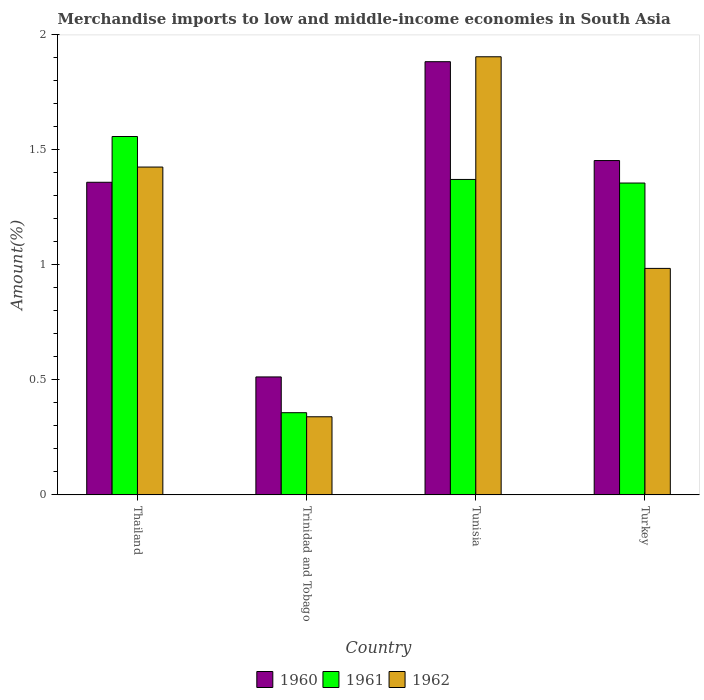How many groups of bars are there?
Your answer should be very brief. 4. Are the number of bars per tick equal to the number of legend labels?
Your answer should be very brief. Yes. How many bars are there on the 4th tick from the left?
Offer a terse response. 3. What is the label of the 1st group of bars from the left?
Your answer should be very brief. Thailand. In how many cases, is the number of bars for a given country not equal to the number of legend labels?
Keep it short and to the point. 0. What is the percentage of amount earned from merchandise imports in 1960 in Tunisia?
Offer a terse response. 1.88. Across all countries, what is the maximum percentage of amount earned from merchandise imports in 1961?
Your response must be concise. 1.56. Across all countries, what is the minimum percentage of amount earned from merchandise imports in 1960?
Provide a succinct answer. 0.51. In which country was the percentage of amount earned from merchandise imports in 1961 maximum?
Offer a terse response. Thailand. In which country was the percentage of amount earned from merchandise imports in 1960 minimum?
Offer a terse response. Trinidad and Tobago. What is the total percentage of amount earned from merchandise imports in 1961 in the graph?
Your answer should be compact. 4.64. What is the difference between the percentage of amount earned from merchandise imports in 1961 in Trinidad and Tobago and that in Tunisia?
Your answer should be very brief. -1.01. What is the difference between the percentage of amount earned from merchandise imports in 1961 in Turkey and the percentage of amount earned from merchandise imports in 1962 in Thailand?
Keep it short and to the point. -0.07. What is the average percentage of amount earned from merchandise imports in 1960 per country?
Make the answer very short. 1.3. What is the difference between the percentage of amount earned from merchandise imports of/in 1960 and percentage of amount earned from merchandise imports of/in 1961 in Tunisia?
Your response must be concise. 0.51. What is the ratio of the percentage of amount earned from merchandise imports in 1960 in Tunisia to that in Turkey?
Offer a very short reply. 1.3. Is the difference between the percentage of amount earned from merchandise imports in 1960 in Thailand and Turkey greater than the difference between the percentage of amount earned from merchandise imports in 1961 in Thailand and Turkey?
Provide a succinct answer. No. What is the difference between the highest and the second highest percentage of amount earned from merchandise imports in 1961?
Your answer should be very brief. 0.2. What is the difference between the highest and the lowest percentage of amount earned from merchandise imports in 1962?
Your answer should be very brief. 1.57. Is it the case that in every country, the sum of the percentage of amount earned from merchandise imports in 1961 and percentage of amount earned from merchandise imports in 1960 is greater than the percentage of amount earned from merchandise imports in 1962?
Provide a short and direct response. Yes. How many bars are there?
Provide a short and direct response. 12. Are all the bars in the graph horizontal?
Make the answer very short. No. How many countries are there in the graph?
Give a very brief answer. 4. Does the graph contain any zero values?
Your response must be concise. No. Does the graph contain grids?
Offer a terse response. No. What is the title of the graph?
Your answer should be compact. Merchandise imports to low and middle-income economies in South Asia. What is the label or title of the Y-axis?
Give a very brief answer. Amount(%). What is the Amount(%) of 1960 in Thailand?
Provide a succinct answer. 1.36. What is the Amount(%) in 1961 in Thailand?
Your answer should be compact. 1.56. What is the Amount(%) in 1962 in Thailand?
Your answer should be compact. 1.43. What is the Amount(%) of 1960 in Trinidad and Tobago?
Keep it short and to the point. 0.51. What is the Amount(%) of 1961 in Trinidad and Tobago?
Offer a very short reply. 0.36. What is the Amount(%) in 1962 in Trinidad and Tobago?
Offer a very short reply. 0.34. What is the Amount(%) in 1960 in Tunisia?
Your answer should be compact. 1.88. What is the Amount(%) in 1961 in Tunisia?
Offer a terse response. 1.37. What is the Amount(%) of 1962 in Tunisia?
Ensure brevity in your answer.  1.91. What is the Amount(%) in 1960 in Turkey?
Your answer should be compact. 1.45. What is the Amount(%) in 1961 in Turkey?
Give a very brief answer. 1.36. What is the Amount(%) in 1962 in Turkey?
Your answer should be compact. 0.98. Across all countries, what is the maximum Amount(%) of 1960?
Provide a short and direct response. 1.88. Across all countries, what is the maximum Amount(%) in 1961?
Provide a short and direct response. 1.56. Across all countries, what is the maximum Amount(%) of 1962?
Make the answer very short. 1.91. Across all countries, what is the minimum Amount(%) in 1960?
Make the answer very short. 0.51. Across all countries, what is the minimum Amount(%) of 1961?
Keep it short and to the point. 0.36. Across all countries, what is the minimum Amount(%) of 1962?
Keep it short and to the point. 0.34. What is the total Amount(%) of 1960 in the graph?
Provide a short and direct response. 5.21. What is the total Amount(%) of 1961 in the graph?
Offer a terse response. 4.64. What is the total Amount(%) in 1962 in the graph?
Provide a short and direct response. 4.66. What is the difference between the Amount(%) in 1960 in Thailand and that in Trinidad and Tobago?
Ensure brevity in your answer.  0.85. What is the difference between the Amount(%) of 1961 in Thailand and that in Trinidad and Tobago?
Make the answer very short. 1.2. What is the difference between the Amount(%) in 1962 in Thailand and that in Trinidad and Tobago?
Provide a short and direct response. 1.09. What is the difference between the Amount(%) in 1960 in Thailand and that in Tunisia?
Provide a short and direct response. -0.52. What is the difference between the Amount(%) of 1961 in Thailand and that in Tunisia?
Ensure brevity in your answer.  0.19. What is the difference between the Amount(%) in 1962 in Thailand and that in Tunisia?
Provide a short and direct response. -0.48. What is the difference between the Amount(%) of 1960 in Thailand and that in Turkey?
Your response must be concise. -0.09. What is the difference between the Amount(%) of 1961 in Thailand and that in Turkey?
Your answer should be very brief. 0.2. What is the difference between the Amount(%) of 1962 in Thailand and that in Turkey?
Ensure brevity in your answer.  0.44. What is the difference between the Amount(%) of 1960 in Trinidad and Tobago and that in Tunisia?
Provide a short and direct response. -1.37. What is the difference between the Amount(%) of 1961 in Trinidad and Tobago and that in Tunisia?
Ensure brevity in your answer.  -1.01. What is the difference between the Amount(%) in 1962 in Trinidad and Tobago and that in Tunisia?
Offer a terse response. -1.57. What is the difference between the Amount(%) in 1960 in Trinidad and Tobago and that in Turkey?
Ensure brevity in your answer.  -0.94. What is the difference between the Amount(%) in 1961 in Trinidad and Tobago and that in Turkey?
Your answer should be very brief. -1. What is the difference between the Amount(%) in 1962 in Trinidad and Tobago and that in Turkey?
Offer a terse response. -0.65. What is the difference between the Amount(%) of 1960 in Tunisia and that in Turkey?
Offer a very short reply. 0.43. What is the difference between the Amount(%) in 1961 in Tunisia and that in Turkey?
Offer a very short reply. 0.02. What is the difference between the Amount(%) in 1962 in Tunisia and that in Turkey?
Offer a very short reply. 0.92. What is the difference between the Amount(%) in 1960 in Thailand and the Amount(%) in 1962 in Trinidad and Tobago?
Your answer should be very brief. 1.02. What is the difference between the Amount(%) in 1961 in Thailand and the Amount(%) in 1962 in Trinidad and Tobago?
Your response must be concise. 1.22. What is the difference between the Amount(%) of 1960 in Thailand and the Amount(%) of 1961 in Tunisia?
Make the answer very short. -0.01. What is the difference between the Amount(%) in 1960 in Thailand and the Amount(%) in 1962 in Tunisia?
Ensure brevity in your answer.  -0.55. What is the difference between the Amount(%) of 1961 in Thailand and the Amount(%) of 1962 in Tunisia?
Give a very brief answer. -0.35. What is the difference between the Amount(%) of 1960 in Thailand and the Amount(%) of 1961 in Turkey?
Provide a succinct answer. 0. What is the difference between the Amount(%) in 1960 in Thailand and the Amount(%) in 1962 in Turkey?
Provide a succinct answer. 0.37. What is the difference between the Amount(%) of 1961 in Thailand and the Amount(%) of 1962 in Turkey?
Offer a very short reply. 0.57. What is the difference between the Amount(%) of 1960 in Trinidad and Tobago and the Amount(%) of 1961 in Tunisia?
Offer a very short reply. -0.86. What is the difference between the Amount(%) in 1960 in Trinidad and Tobago and the Amount(%) in 1962 in Tunisia?
Provide a short and direct response. -1.39. What is the difference between the Amount(%) of 1961 in Trinidad and Tobago and the Amount(%) of 1962 in Tunisia?
Keep it short and to the point. -1.55. What is the difference between the Amount(%) of 1960 in Trinidad and Tobago and the Amount(%) of 1961 in Turkey?
Provide a succinct answer. -0.84. What is the difference between the Amount(%) of 1960 in Trinidad and Tobago and the Amount(%) of 1962 in Turkey?
Make the answer very short. -0.47. What is the difference between the Amount(%) in 1961 in Trinidad and Tobago and the Amount(%) in 1962 in Turkey?
Provide a succinct answer. -0.63. What is the difference between the Amount(%) in 1960 in Tunisia and the Amount(%) in 1961 in Turkey?
Provide a succinct answer. 0.53. What is the difference between the Amount(%) of 1960 in Tunisia and the Amount(%) of 1962 in Turkey?
Provide a succinct answer. 0.9. What is the difference between the Amount(%) in 1961 in Tunisia and the Amount(%) in 1962 in Turkey?
Ensure brevity in your answer.  0.39. What is the average Amount(%) in 1960 per country?
Your answer should be compact. 1.3. What is the average Amount(%) of 1961 per country?
Ensure brevity in your answer.  1.16. What is the average Amount(%) of 1962 per country?
Make the answer very short. 1.16. What is the difference between the Amount(%) of 1960 and Amount(%) of 1961 in Thailand?
Give a very brief answer. -0.2. What is the difference between the Amount(%) of 1960 and Amount(%) of 1962 in Thailand?
Make the answer very short. -0.07. What is the difference between the Amount(%) of 1961 and Amount(%) of 1962 in Thailand?
Provide a succinct answer. 0.13. What is the difference between the Amount(%) in 1960 and Amount(%) in 1961 in Trinidad and Tobago?
Keep it short and to the point. 0.16. What is the difference between the Amount(%) in 1960 and Amount(%) in 1962 in Trinidad and Tobago?
Make the answer very short. 0.17. What is the difference between the Amount(%) of 1961 and Amount(%) of 1962 in Trinidad and Tobago?
Your answer should be very brief. 0.02. What is the difference between the Amount(%) in 1960 and Amount(%) in 1961 in Tunisia?
Provide a succinct answer. 0.51. What is the difference between the Amount(%) of 1960 and Amount(%) of 1962 in Tunisia?
Offer a very short reply. -0.02. What is the difference between the Amount(%) in 1961 and Amount(%) in 1962 in Tunisia?
Ensure brevity in your answer.  -0.53. What is the difference between the Amount(%) of 1960 and Amount(%) of 1961 in Turkey?
Provide a succinct answer. 0.1. What is the difference between the Amount(%) of 1960 and Amount(%) of 1962 in Turkey?
Ensure brevity in your answer.  0.47. What is the difference between the Amount(%) of 1961 and Amount(%) of 1962 in Turkey?
Provide a succinct answer. 0.37. What is the ratio of the Amount(%) of 1960 in Thailand to that in Trinidad and Tobago?
Ensure brevity in your answer.  2.65. What is the ratio of the Amount(%) of 1961 in Thailand to that in Trinidad and Tobago?
Make the answer very short. 4.36. What is the ratio of the Amount(%) of 1962 in Thailand to that in Trinidad and Tobago?
Give a very brief answer. 4.2. What is the ratio of the Amount(%) of 1960 in Thailand to that in Tunisia?
Offer a terse response. 0.72. What is the ratio of the Amount(%) in 1961 in Thailand to that in Tunisia?
Keep it short and to the point. 1.14. What is the ratio of the Amount(%) in 1962 in Thailand to that in Tunisia?
Offer a very short reply. 0.75. What is the ratio of the Amount(%) of 1960 in Thailand to that in Turkey?
Make the answer very short. 0.94. What is the ratio of the Amount(%) in 1961 in Thailand to that in Turkey?
Your response must be concise. 1.15. What is the ratio of the Amount(%) of 1962 in Thailand to that in Turkey?
Your answer should be very brief. 1.45. What is the ratio of the Amount(%) in 1960 in Trinidad and Tobago to that in Tunisia?
Your answer should be very brief. 0.27. What is the ratio of the Amount(%) of 1961 in Trinidad and Tobago to that in Tunisia?
Make the answer very short. 0.26. What is the ratio of the Amount(%) of 1962 in Trinidad and Tobago to that in Tunisia?
Provide a short and direct response. 0.18. What is the ratio of the Amount(%) of 1960 in Trinidad and Tobago to that in Turkey?
Offer a very short reply. 0.35. What is the ratio of the Amount(%) of 1961 in Trinidad and Tobago to that in Turkey?
Make the answer very short. 0.26. What is the ratio of the Amount(%) in 1962 in Trinidad and Tobago to that in Turkey?
Ensure brevity in your answer.  0.34. What is the ratio of the Amount(%) of 1960 in Tunisia to that in Turkey?
Your response must be concise. 1.3. What is the ratio of the Amount(%) in 1961 in Tunisia to that in Turkey?
Your answer should be very brief. 1.01. What is the ratio of the Amount(%) of 1962 in Tunisia to that in Turkey?
Ensure brevity in your answer.  1.93. What is the difference between the highest and the second highest Amount(%) in 1960?
Keep it short and to the point. 0.43. What is the difference between the highest and the second highest Amount(%) of 1961?
Give a very brief answer. 0.19. What is the difference between the highest and the second highest Amount(%) of 1962?
Offer a terse response. 0.48. What is the difference between the highest and the lowest Amount(%) of 1960?
Keep it short and to the point. 1.37. What is the difference between the highest and the lowest Amount(%) of 1961?
Keep it short and to the point. 1.2. What is the difference between the highest and the lowest Amount(%) of 1962?
Your answer should be very brief. 1.57. 